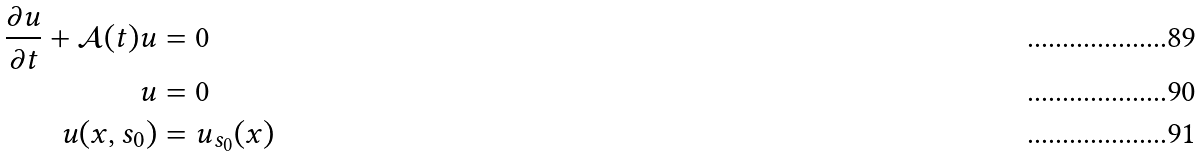Convert formula to latex. <formula><loc_0><loc_0><loc_500><loc_500>\frac { \partial u } { \partial t } + \mathcal { A } ( t ) u & = 0 & & \\ u & = 0 & & \\ u ( x , s _ { 0 } ) & = u _ { s _ { 0 } } ( x ) & &</formula> 